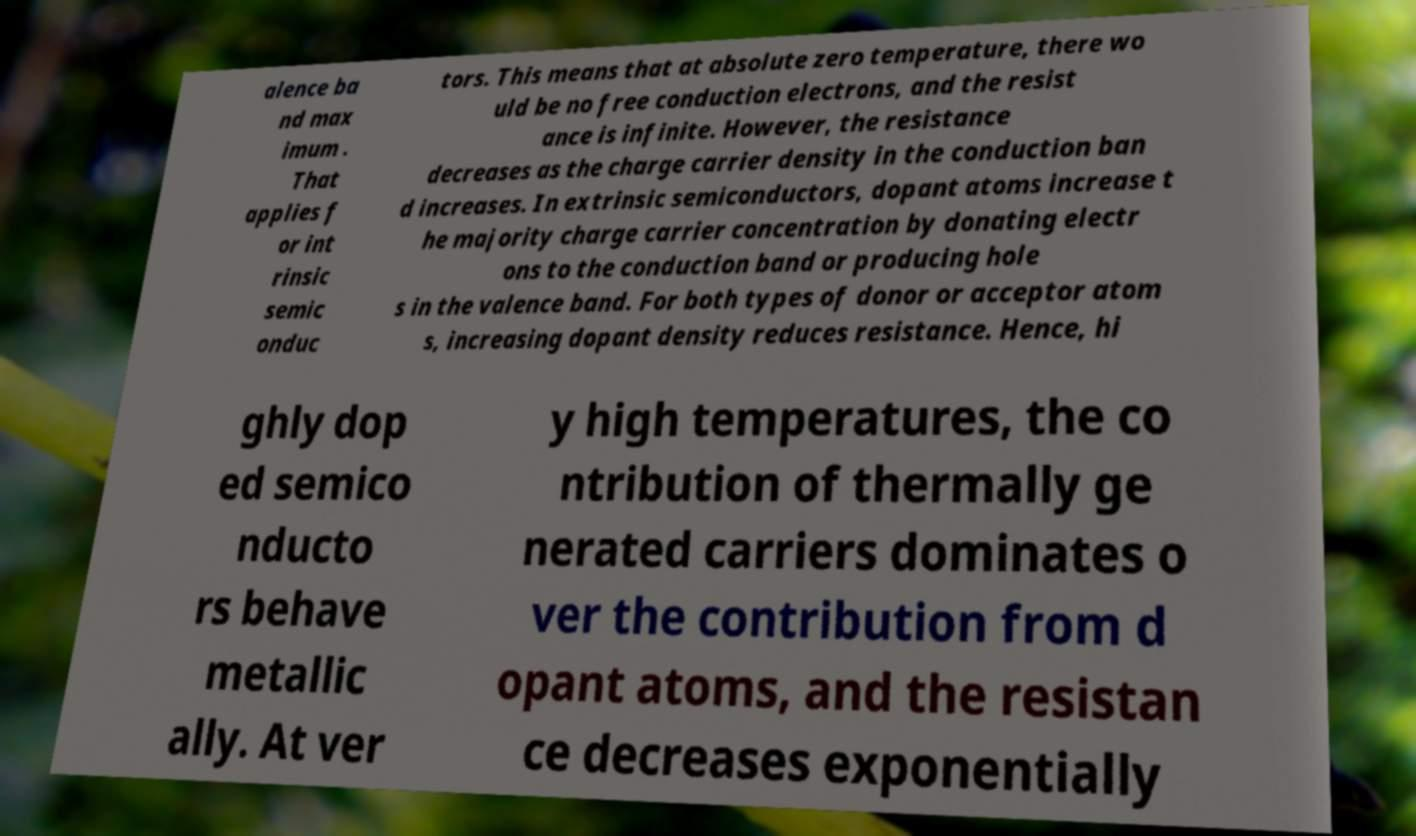There's text embedded in this image that I need extracted. Can you transcribe it verbatim? alence ba nd max imum . That applies f or int rinsic semic onduc tors. This means that at absolute zero temperature, there wo uld be no free conduction electrons, and the resist ance is infinite. However, the resistance decreases as the charge carrier density in the conduction ban d increases. In extrinsic semiconductors, dopant atoms increase t he majority charge carrier concentration by donating electr ons to the conduction band or producing hole s in the valence band. For both types of donor or acceptor atom s, increasing dopant density reduces resistance. Hence, hi ghly dop ed semico nducto rs behave metallic ally. At ver y high temperatures, the co ntribution of thermally ge nerated carriers dominates o ver the contribution from d opant atoms, and the resistan ce decreases exponentially 